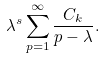<formula> <loc_0><loc_0><loc_500><loc_500>\lambda ^ { s } \sum _ { p = 1 } ^ { \infty } \frac { C _ { k } } { p - \lambda } .</formula> 